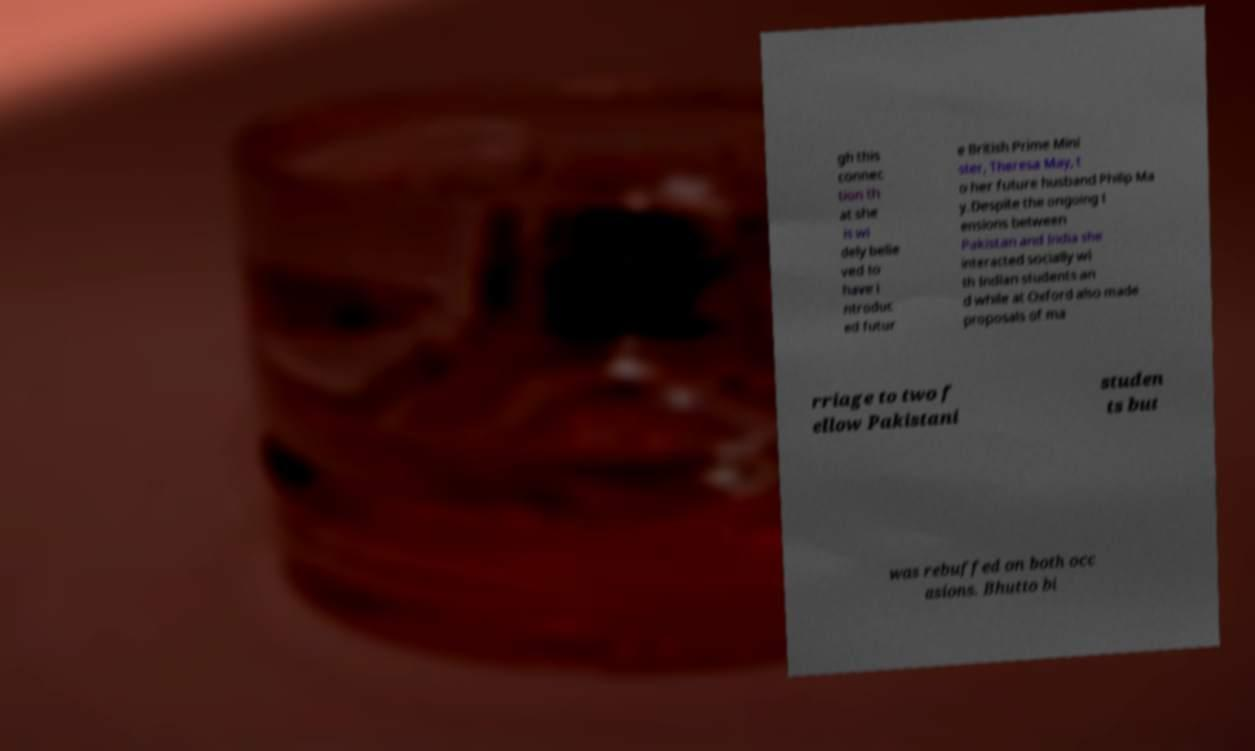Could you assist in decoding the text presented in this image and type it out clearly? gh this connec tion th at she is wi dely belie ved to have i ntroduc ed futur e British Prime Mini ster, Theresa May, t o her future husband Philip Ma y.Despite the ongoing t ensions between Pakistan and India she interacted socially wi th Indian students an d while at Oxford also made proposals of ma rriage to two f ellow Pakistani studen ts but was rebuffed on both occ asions. Bhutto bi 